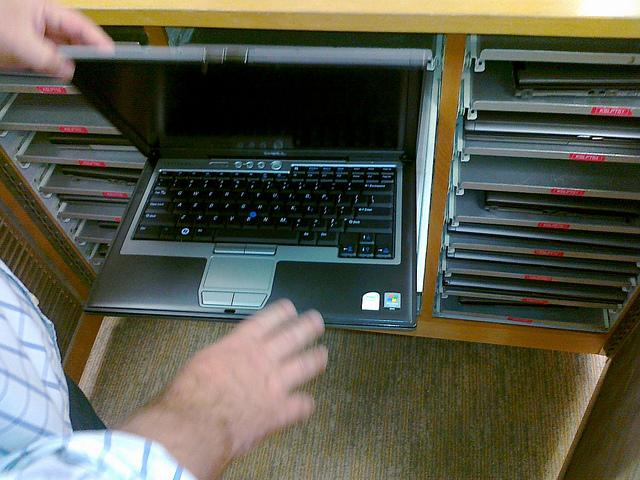What word is associated with the item the person is touching?

Choices:
A) space bar
B) orange
C) puppy
D) baby space bar 